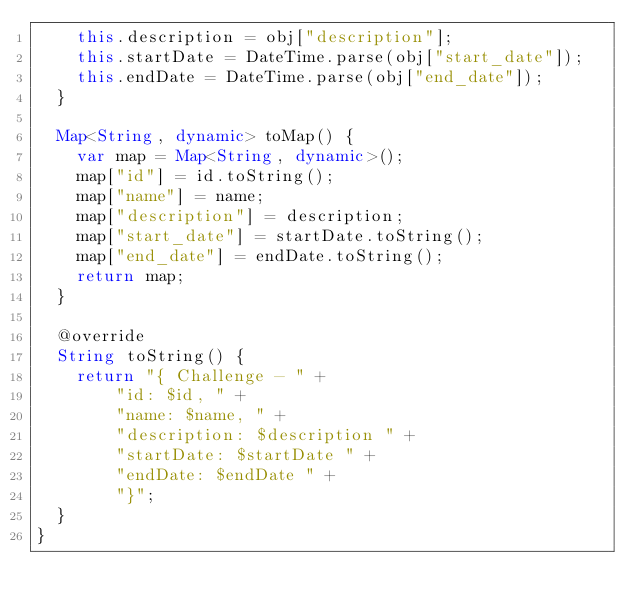<code> <loc_0><loc_0><loc_500><loc_500><_Dart_>    this.description = obj["description"];
    this.startDate = DateTime.parse(obj["start_date"]);
    this.endDate = DateTime.parse(obj["end_date"]);
  }

  Map<String, dynamic> toMap() {
    var map = Map<String, dynamic>();
    map["id"] = id.toString();
    map["name"] = name;
    map["description"] = description;
    map["start_date"] = startDate.toString();
    map["end_date"] = endDate.toString();
    return map;
  }

  @override
  String toString() {
    return "{ Challenge - " +
        "id: $id, " +
        "name: $name, " +
        "description: $description " +
        "startDate: $startDate " +
        "endDate: $endDate " +
        "}";
  }
}
</code> 